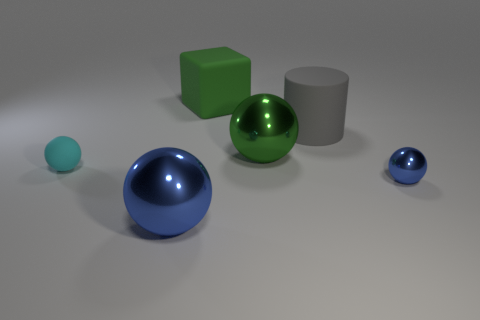Which object seems closest to the point of view and why? The blue sphere in the foreground appears to be the closest to the point of view, mainly because it is larger than the other items in terms of perspective, and it obscures part of the green sphere and the cylinder, indicating that it is in front of them. 